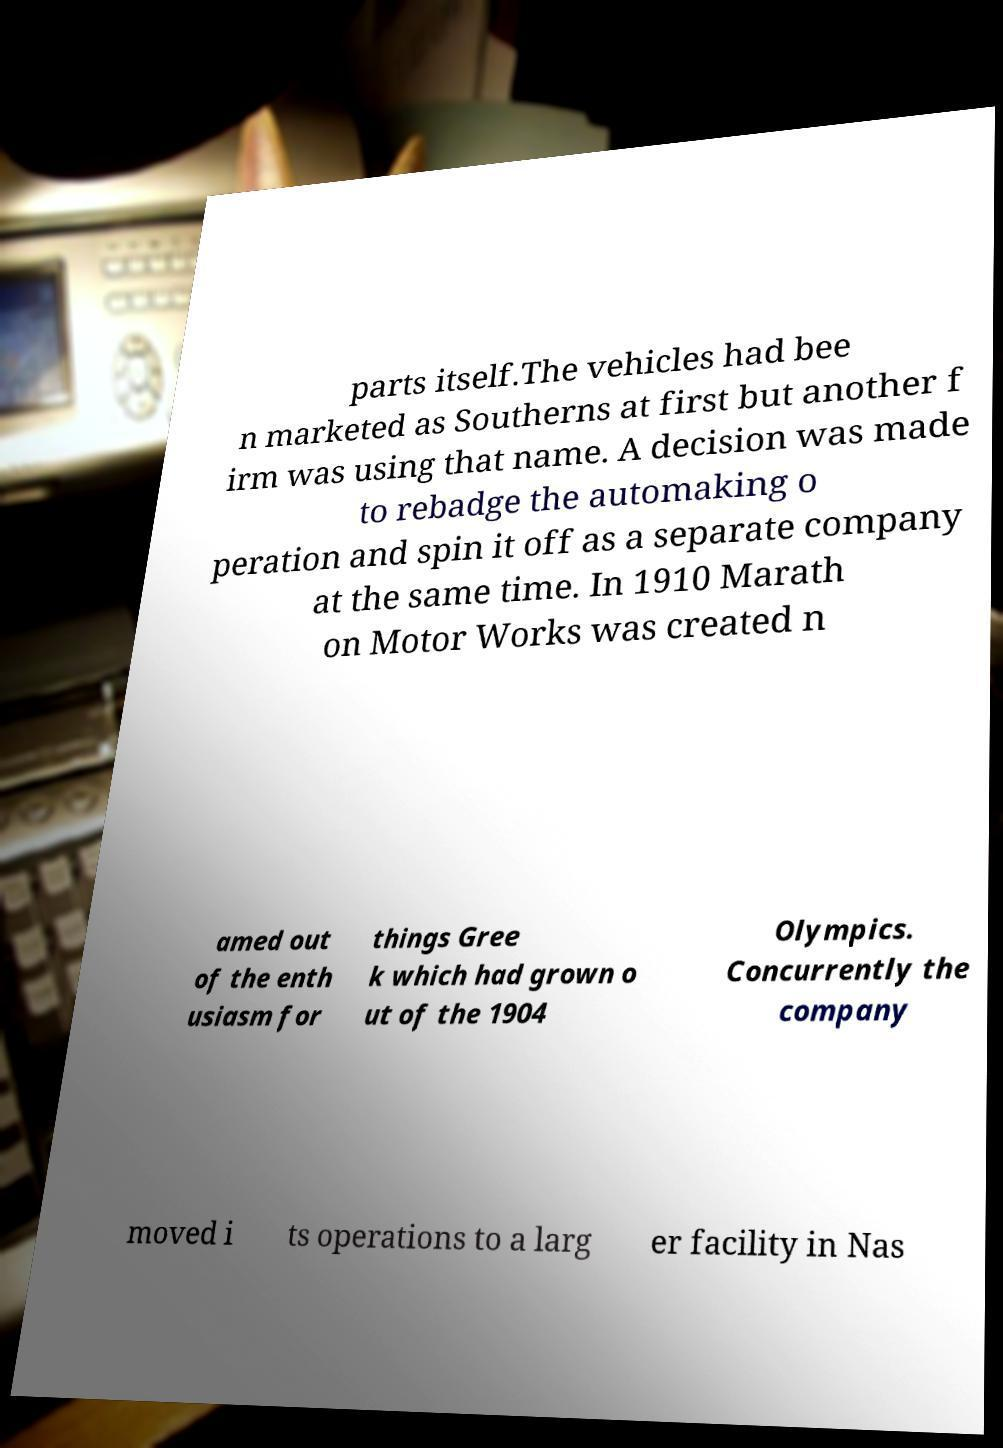Can you accurately transcribe the text from the provided image for me? parts itself.The vehicles had bee n marketed as Southerns at first but another f irm was using that name. A decision was made to rebadge the automaking o peration and spin it off as a separate company at the same time. In 1910 Marath on Motor Works was created n amed out of the enth usiasm for things Gree k which had grown o ut of the 1904 Olympics. Concurrently the company moved i ts operations to a larg er facility in Nas 